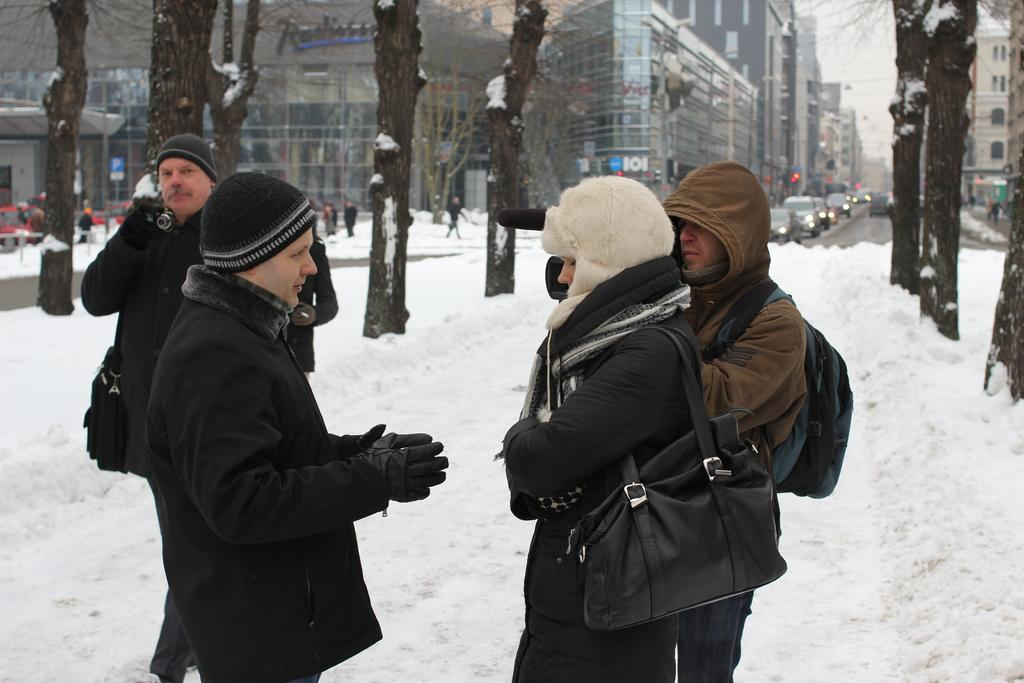What is the main subject in the center of the image? There are people in the center of the image. What is the condition of the ground in the center of the image? There is snow in the center of the image. What can be seen in the background of the image? There are buildings and trees in the background of the image. What type of coal is being used to bake the bun in the image? There is no coal or bun present in the image; it features people in the snow with buildings and trees in the background. 